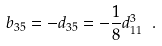Convert formula to latex. <formula><loc_0><loc_0><loc_500><loc_500>b _ { 3 5 } = - d _ { 3 5 } = - \frac { 1 } { 8 } d _ { 1 1 } ^ { 3 } \ .</formula> 